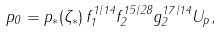<formula> <loc_0><loc_0><loc_500><loc_500>p _ { 0 } = p _ { * } ( \zeta _ { * } ) \, f _ { 1 } ^ { 1 / 1 4 } f _ { 2 } ^ { 1 5 / 2 8 } g _ { 2 } ^ { 1 7 / 1 4 } U _ { p } ,</formula> 